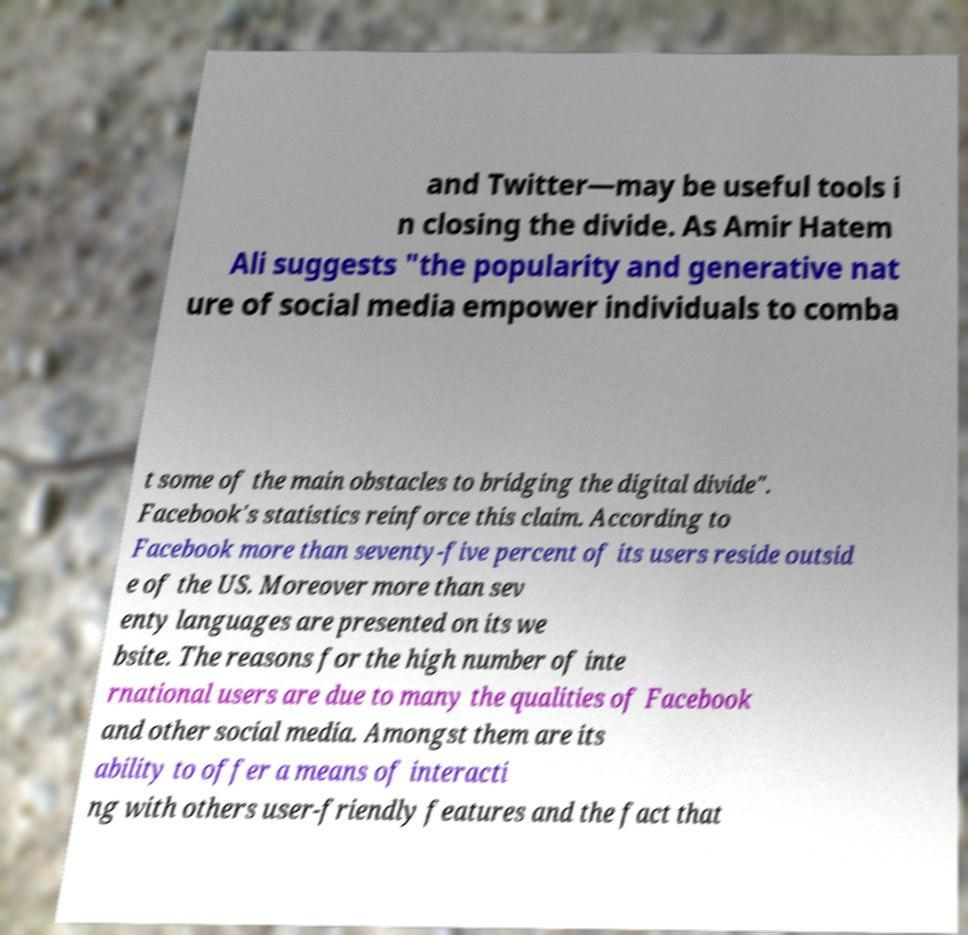Can you read and provide the text displayed in the image?This photo seems to have some interesting text. Can you extract and type it out for me? and Twitter—may be useful tools i n closing the divide. As Amir Hatem Ali suggests "the popularity and generative nat ure of social media empower individuals to comba t some of the main obstacles to bridging the digital divide". Facebook's statistics reinforce this claim. According to Facebook more than seventy-five percent of its users reside outsid e of the US. Moreover more than sev enty languages are presented on its we bsite. The reasons for the high number of inte rnational users are due to many the qualities of Facebook and other social media. Amongst them are its ability to offer a means of interacti ng with others user-friendly features and the fact that 